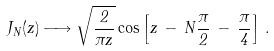<formula> <loc_0><loc_0><loc_500><loc_500>J _ { N } ( z ) \longrightarrow \sqrt { \frac { 2 } { \pi z } } \cos \left [ z \, - \, N \frac { \pi } 2 \, - \, \frac { \pi } 4 \right ] \, .</formula> 